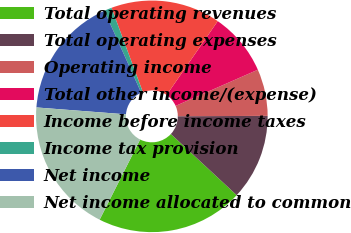<chart> <loc_0><loc_0><loc_500><loc_500><pie_chart><fcel>Total operating revenues<fcel>Total operating expenses<fcel>Operating income<fcel>Total other income/(expense)<fcel>Income before income taxes<fcel>Income tax provision<fcel>Net income<fcel>Net income allocated to common<nl><fcel>20.53%<fcel>11.98%<fcel>6.53%<fcel>8.77%<fcel>15.3%<fcel>1.07%<fcel>17.04%<fcel>18.78%<nl></chart> 